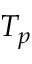Convert formula to latex. <formula><loc_0><loc_0><loc_500><loc_500>T _ { p }</formula> 